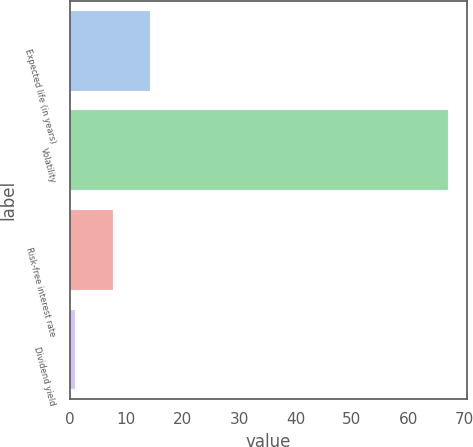Convert chart to OTSL. <chart><loc_0><loc_0><loc_500><loc_500><bar_chart><fcel>Expected life (in years)<fcel>Volatility<fcel>Risk-free interest rate<fcel>Dividend yield<nl><fcel>14.17<fcel>67<fcel>7.57<fcel>0.97<nl></chart> 